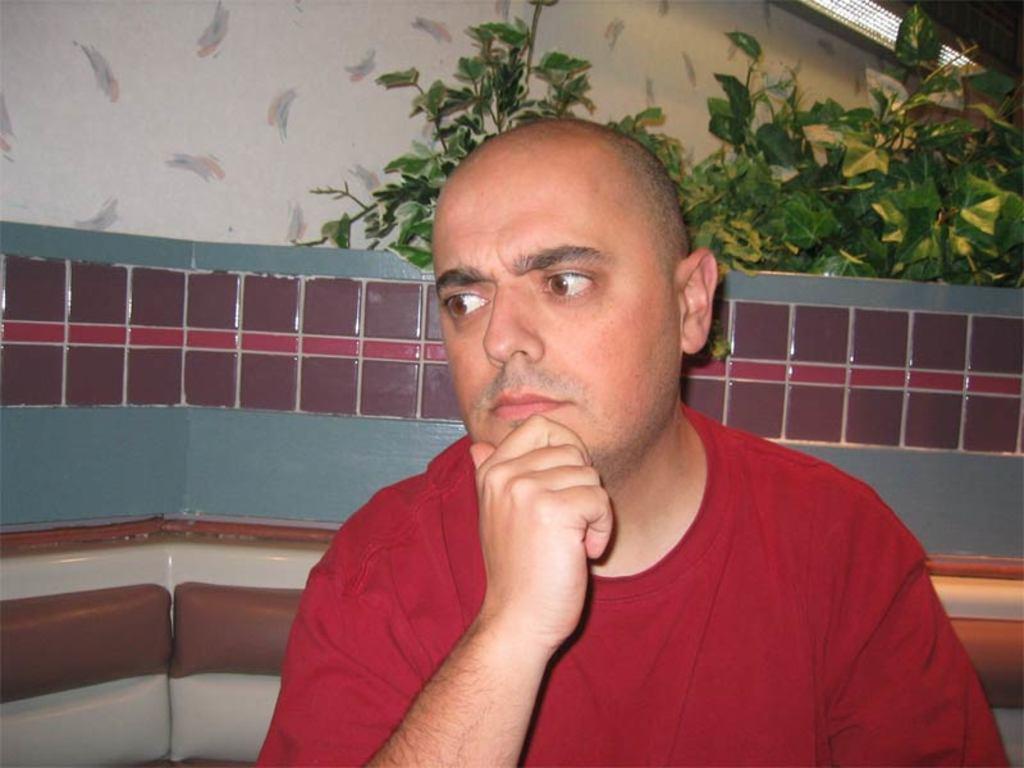Could you give a brief overview of what you see in this image? In this picture we can see a man, he wore a red color T-shirt, behind to him we can see few plants. 